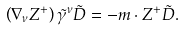Convert formula to latex. <formula><loc_0><loc_0><loc_500><loc_500>\left ( { \nabla _ { \nu } Z ^ { + } } \right ) \tilde { \gamma } ^ { \nu } \tilde { D } = - m \cdot Z ^ { + } \tilde { D } .</formula> 